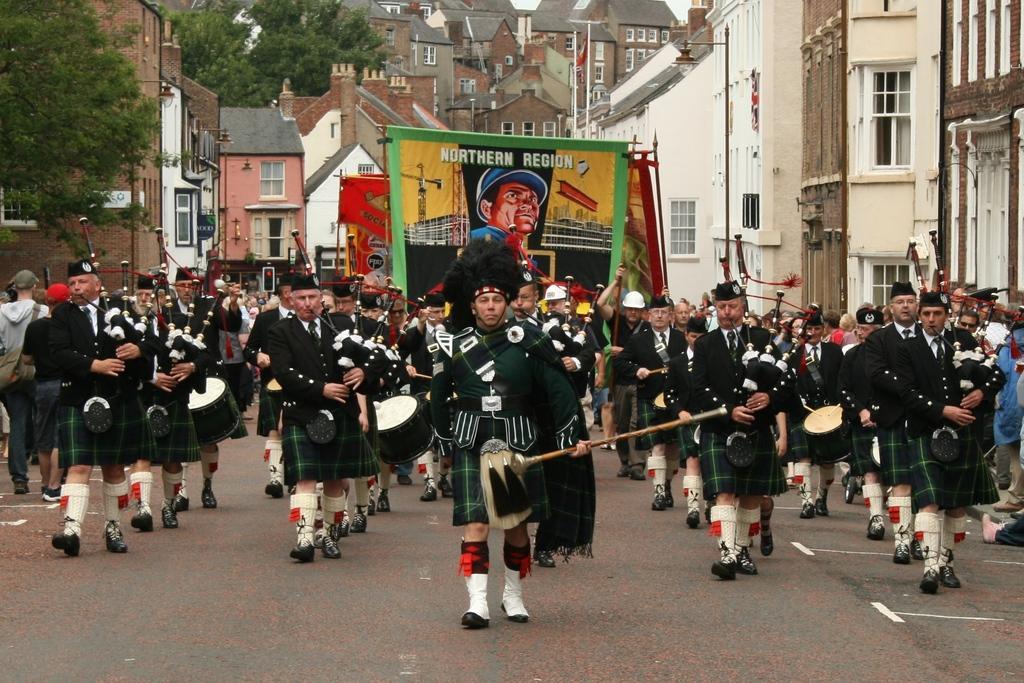In one or two sentences, can you explain what this image depicts? In this image I can see a crowd is playing musical instruments on the road. In the background I can see a poster, buildings, light poles, windows and trees. This image is taken on the road during a day. 